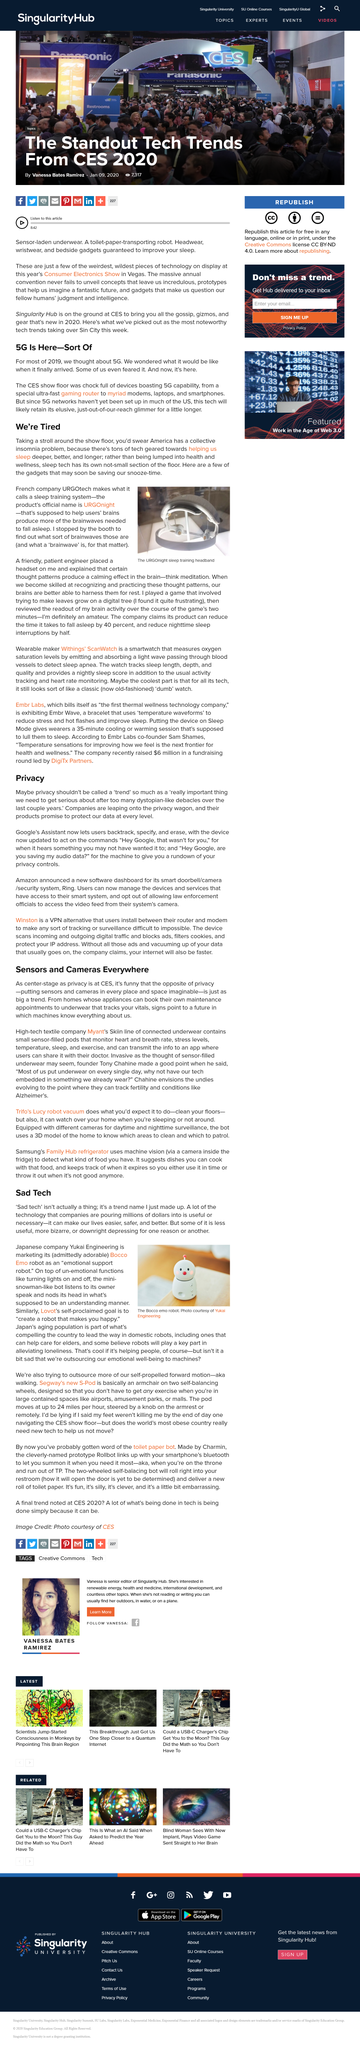Point out several critical features in this image. The engineering company being discussed in the article is Japanese. What privacy is valued at CES when Myant's Skiin's line of sensor-filled underwear is violated? There is technology available that is designed to improve the quality of sleep, including devices that promote deeper, more restful sleep. Laptops are capable of hosting 5G service. Google's Assistant now allows users to backtrack, specify, and erase previous commands. 